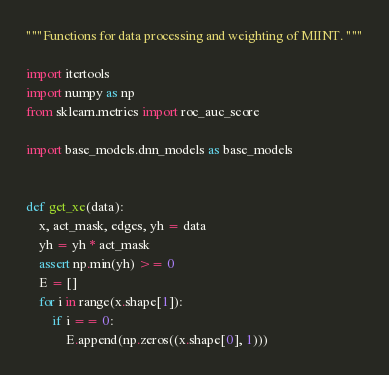Convert code to text. <code><loc_0><loc_0><loc_500><loc_500><_Python_>"""Functions for data processing and weighting of MIINT. """

import itertools
import numpy as np
from sklearn.metrics import roc_auc_score

import base_models.dnn_models as base_models


def get_xe(data):
	x, act_mask, edges, yh = data
	yh = yh * act_mask
	assert np.min(yh) >= 0
	E = []
	for i in range(x.shape[1]):
		if i == 0:
			E.append(np.zeros((x.shape[0], 1)))</code> 